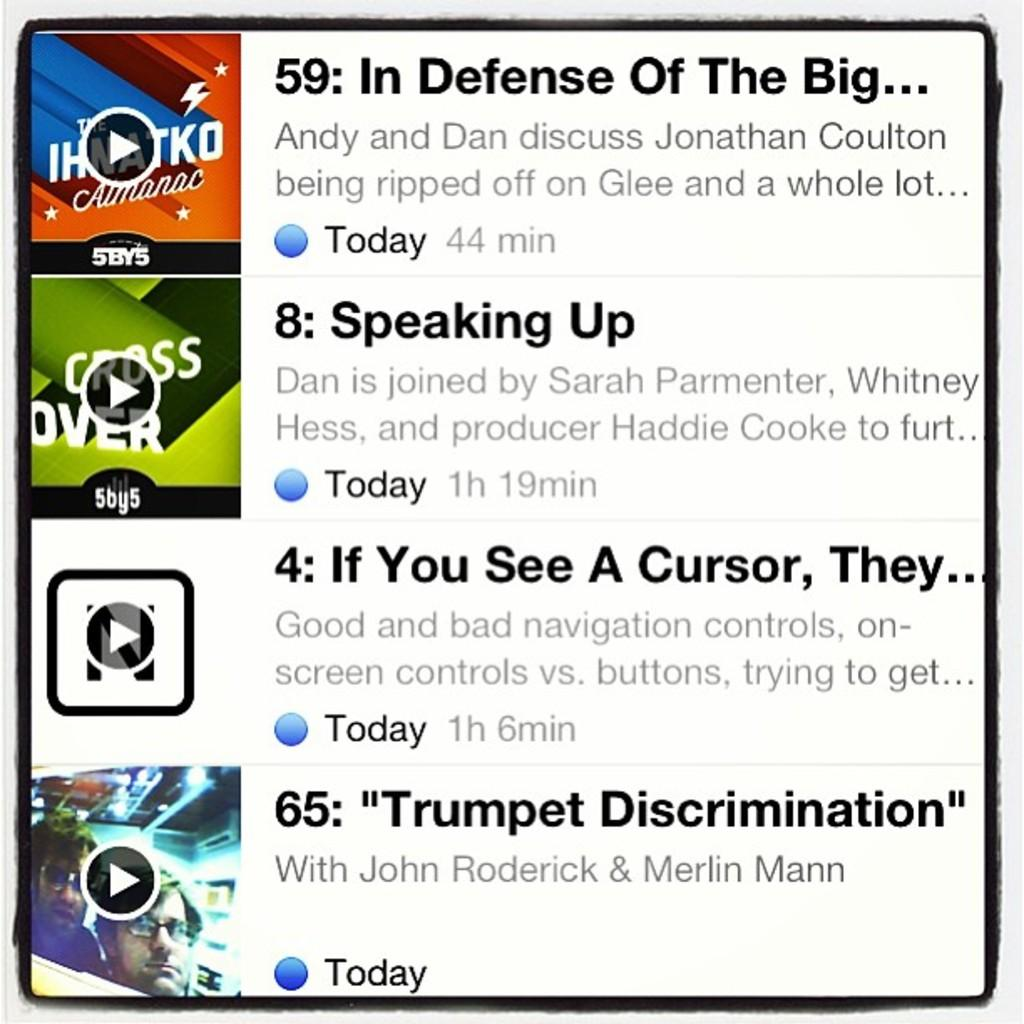What type of image is being displayed? The image is a screenshot. What can be found within the screenshot? There are headlines in the image. What type of plantation is shown in the image? There is no plantation present in the image; it is a screenshot with headlines. How does the growth of the vest impact the image? There is no vest or growth mentioned in the image; it only contains headlines. 